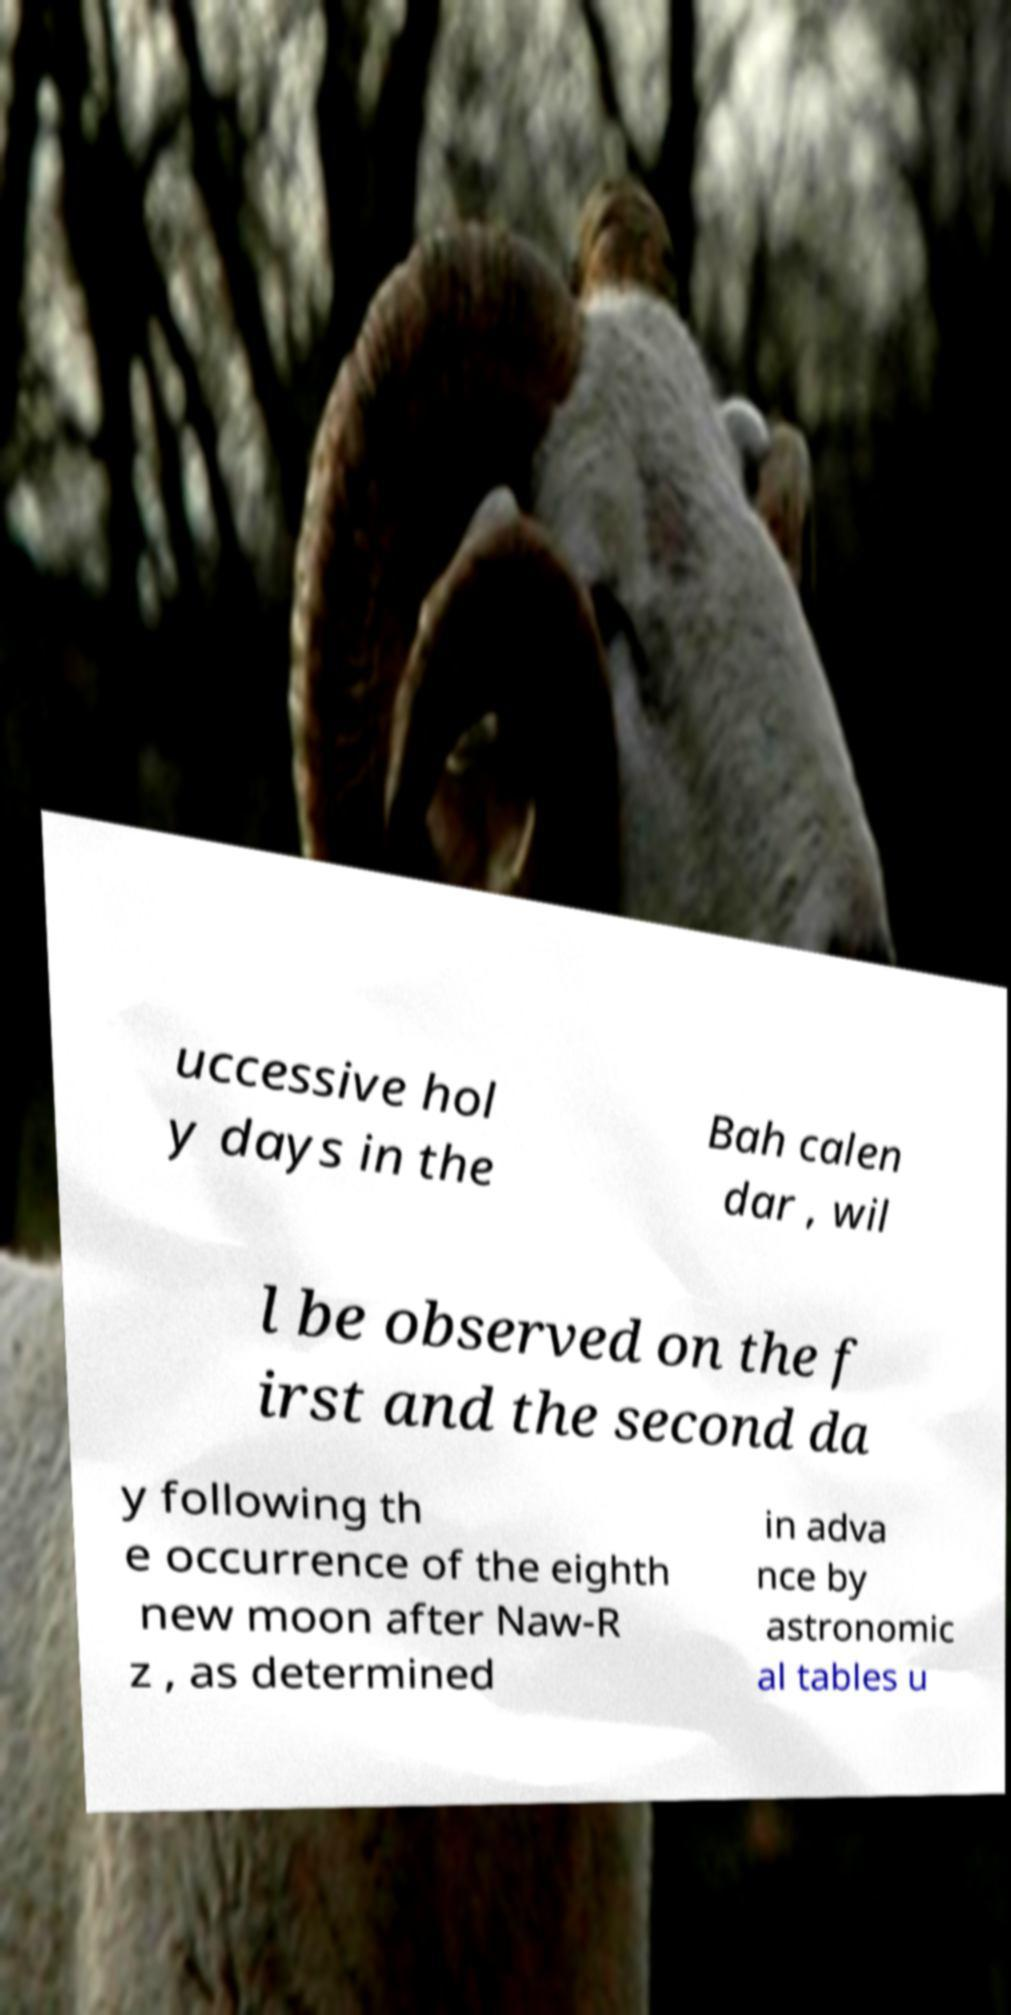Can you read and provide the text displayed in the image?This photo seems to have some interesting text. Can you extract and type it out for me? uccessive hol y days in the Bah calen dar , wil l be observed on the f irst and the second da y following th e occurrence of the eighth new moon after Naw-R z , as determined in adva nce by astronomic al tables u 